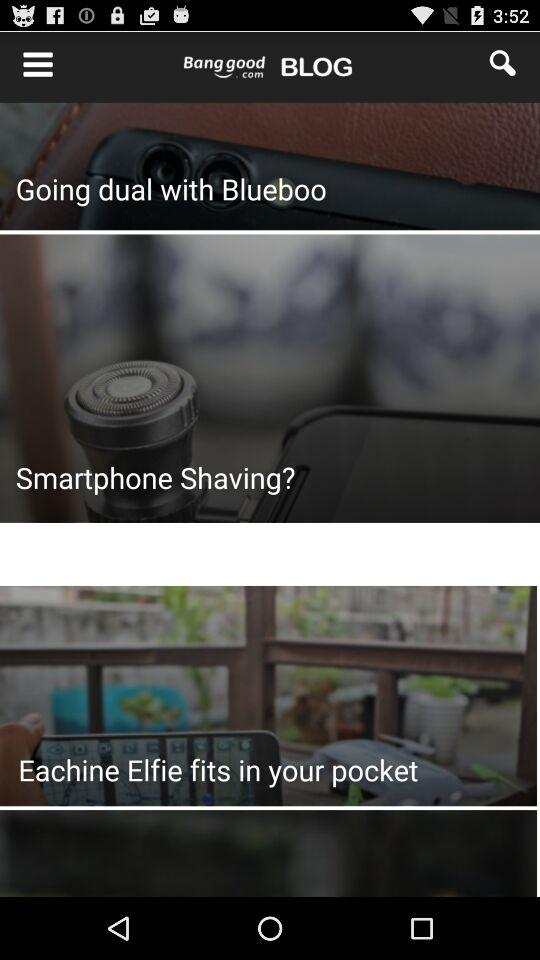What is the price of the "Kennel Pillow Puppy Cushion"? The price of the "Kennel Pillow Puppy Cushion" is $3.99. 